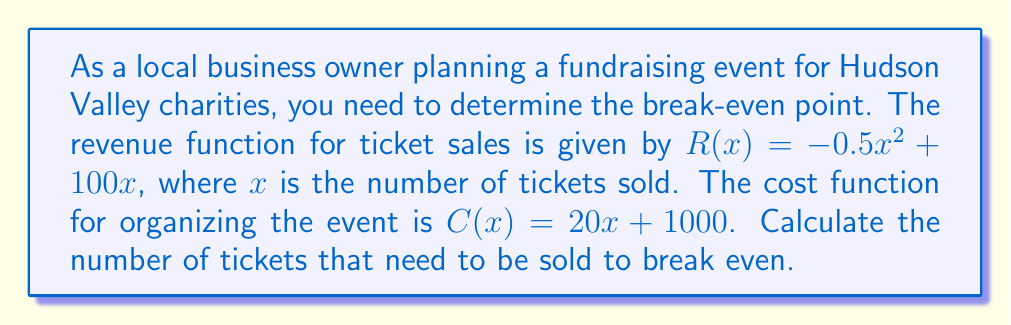Could you help me with this problem? To find the break-even point, we need to determine where the revenue equals the cost. This can be done by setting up and solving the equation:

$$R(x) = C(x)$$

Let's substitute the given functions:

$$-0.5x^2 + 100x = 20x + 1000$$

Now, let's solve this equation:

1) First, subtract $20x$ from both sides:
   $$-0.5x^2 + 80x = 1000$$

2) Rearrange to standard form:
   $$-0.5x^2 + 80x - 1000 = 0$$

3) Multiply everything by -2 to make the coefficient of $x^2$ positive:
   $$x^2 - 160x + 2000 = 0$$

4) This is a quadratic equation. We can solve it using the quadratic formula:
   $$x = \frac{-b \pm \sqrt{b^2 - 4ac}}{2a}$$
   where $a = 1$, $b = -160$, and $c = 2000$

5) Substituting these values:
   $$x = \frac{160 \pm \sqrt{(-160)^2 - 4(1)(2000)}}{2(1)}$$

6) Simplify:
   $$x = \frac{160 \pm \sqrt{25600 - 8000}}{2} = \frac{160 \pm \sqrt{17600}}{2} = \frac{160 \pm 132.66}{2}$$

7) This gives us two solutions:
   $$x_1 = \frac{160 + 132.66}{2} \approx 146.33$$
   $$x_2 = \frac{160 - 132.66}{2} \approx 13.67$$

8) Since we're dealing with ticket sales, we need a positive, whole number. Therefore, we round up to the nearest integer for the larger solution.
Answer: The break-even point is 147 tickets. The fundraising event needs to sell at least 147 tickets to break even. 